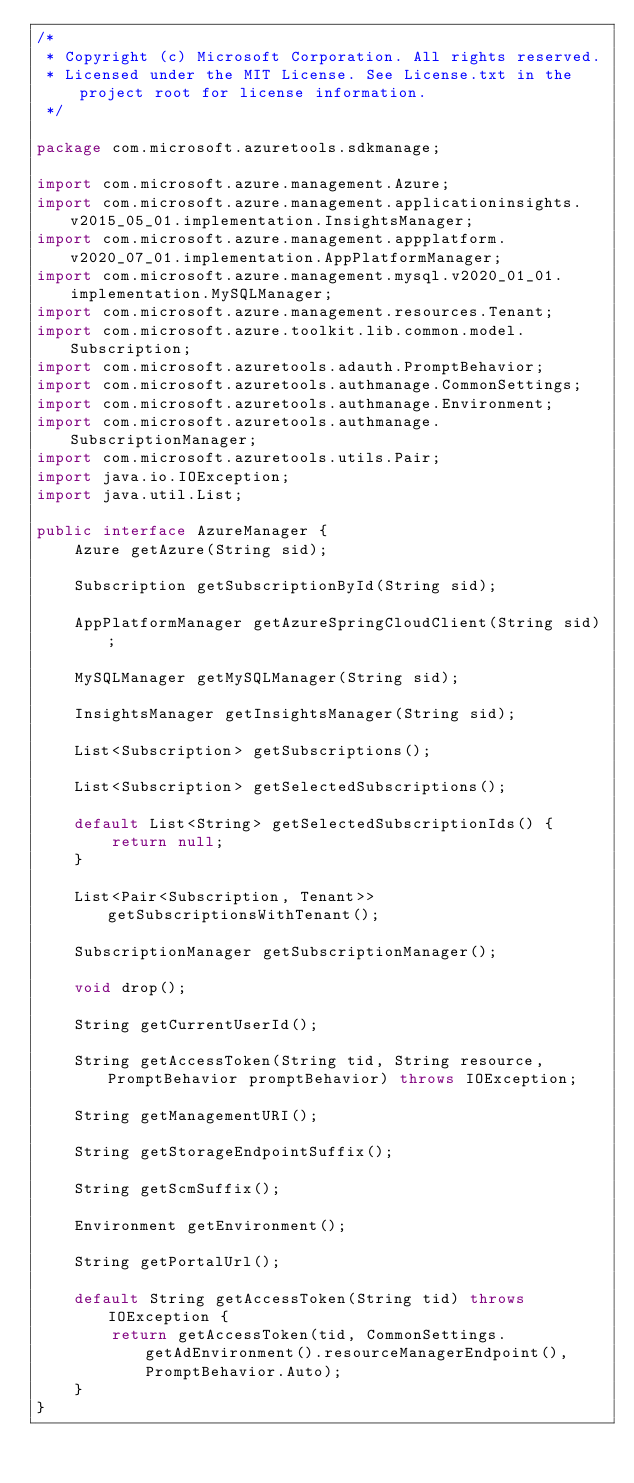<code> <loc_0><loc_0><loc_500><loc_500><_Java_>/*
 * Copyright (c) Microsoft Corporation. All rights reserved.
 * Licensed under the MIT License. See License.txt in the project root for license information.
 */

package com.microsoft.azuretools.sdkmanage;

import com.microsoft.azure.management.Azure;
import com.microsoft.azure.management.applicationinsights.v2015_05_01.implementation.InsightsManager;
import com.microsoft.azure.management.appplatform.v2020_07_01.implementation.AppPlatformManager;
import com.microsoft.azure.management.mysql.v2020_01_01.implementation.MySQLManager;
import com.microsoft.azure.management.resources.Tenant;
import com.microsoft.azure.toolkit.lib.common.model.Subscription;
import com.microsoft.azuretools.adauth.PromptBehavior;
import com.microsoft.azuretools.authmanage.CommonSettings;
import com.microsoft.azuretools.authmanage.Environment;
import com.microsoft.azuretools.authmanage.SubscriptionManager;
import com.microsoft.azuretools.utils.Pair;
import java.io.IOException;
import java.util.List;

public interface AzureManager {
    Azure getAzure(String sid);

    Subscription getSubscriptionById(String sid);

    AppPlatformManager getAzureSpringCloudClient(String sid);

    MySQLManager getMySQLManager(String sid);

    InsightsManager getInsightsManager(String sid);

    List<Subscription> getSubscriptions();

    List<Subscription> getSelectedSubscriptions();

    default List<String> getSelectedSubscriptionIds() {
        return null;
    }

    List<Pair<Subscription, Tenant>> getSubscriptionsWithTenant();

    SubscriptionManager getSubscriptionManager();

    void drop();

    String getCurrentUserId();

    String getAccessToken(String tid, String resource, PromptBehavior promptBehavior) throws IOException;

    String getManagementURI();

    String getStorageEndpointSuffix();

    String getScmSuffix();

    Environment getEnvironment();

    String getPortalUrl();

    default String getAccessToken(String tid) throws IOException {
        return getAccessToken(tid, CommonSettings.getAdEnvironment().resourceManagerEndpoint(), PromptBehavior.Auto);
    }
}
</code> 